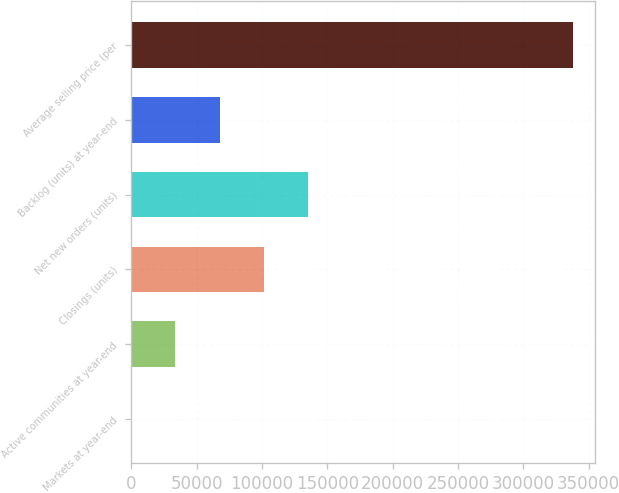Convert chart. <chart><loc_0><loc_0><loc_500><loc_500><bar_chart><fcel>Markets at year-end<fcel>Active communities at year-end<fcel>Closings (units)<fcel>Net new orders (units)<fcel>Backlog (units) at year-end<fcel>Average selling price (per<nl><fcel>50<fcel>33845<fcel>101435<fcel>135230<fcel>67640<fcel>338000<nl></chart> 